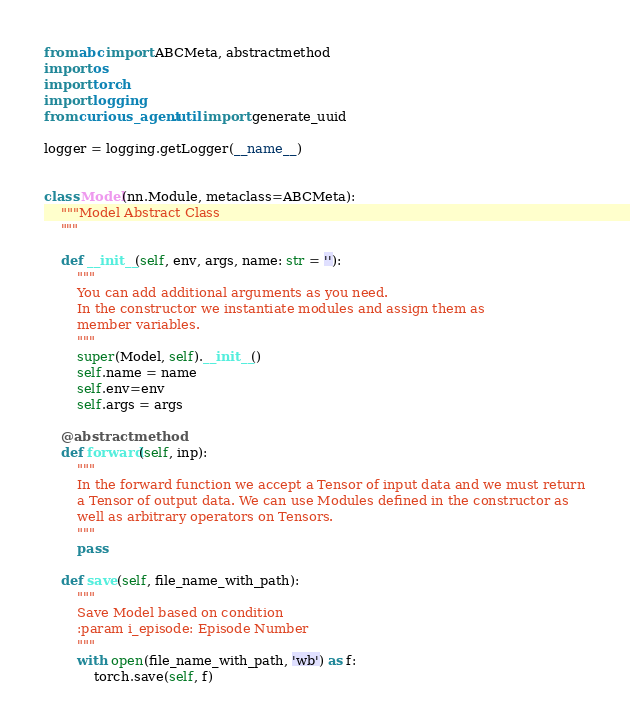Convert code to text. <code><loc_0><loc_0><loc_500><loc_500><_Python_>from abc import ABCMeta, abstractmethod
import os
import torch
import logging
from curious_agent.util import generate_uuid

logger = logging.getLogger(__name__)


class Model(nn.Module, metaclass=ABCMeta):
    """Model Abstract Class
    """

    def __init__(self, env, args, name: str = ''):
        """
        You can add additional arguments as you need.
        In the constructor we instantiate modules and assign them as
        member variables.
        """
        super(Model, self).__init__()
        self.name = name
        self.env=env
        self.args = args

    @abstractmethod
    def forward(self, inp):
        """
        In the forward function we accept a Tensor of input data and we must return
        a Tensor of output data. We can use Modules defined in the constructor as
        well as arbitrary operators on Tensors.
        """
        pass

    def save(self, file_name_with_path):
        """
        Save Model based on condition
        :param i_episode: Episode Number
        """
        with open(file_name_with_path, 'wb') as f:
            torch.save(self, f)</code> 